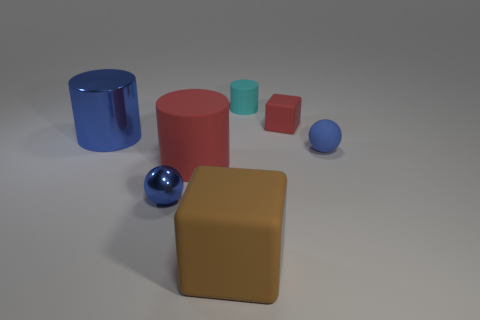How would you describe the composition and colors of the objects in this scene? The composition of the scene is a balanced arrangement of geometric shapes that include two cylinders, two cubes, and two spheres. The colors displayed range from muted to vibrant, with a blue metallic cylinder, a matte red cylinder, a tan cube, a smaller light blue cylinder, a small orange cube, and two spheres—one blue and metallic, the other in a soft light blue. The varying sizes and colors create a visually interesting tableau. 